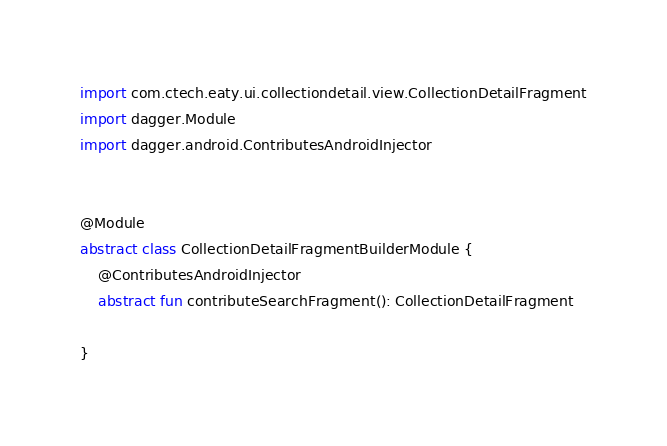<code> <loc_0><loc_0><loc_500><loc_500><_Kotlin_>import com.ctech.eaty.ui.collectiondetail.view.CollectionDetailFragment
import dagger.Module
import dagger.android.ContributesAndroidInjector


@Module
abstract class CollectionDetailFragmentBuilderModule {
    @ContributesAndroidInjector
    abstract fun contributeSearchFragment(): CollectionDetailFragment

}</code> 